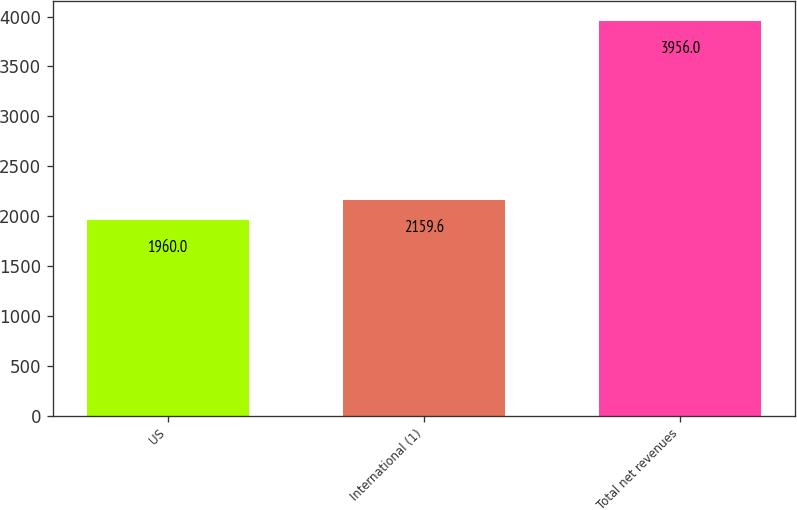<chart> <loc_0><loc_0><loc_500><loc_500><bar_chart><fcel>US<fcel>International (1)<fcel>Total net revenues<nl><fcel>1960<fcel>2159.6<fcel>3956<nl></chart> 